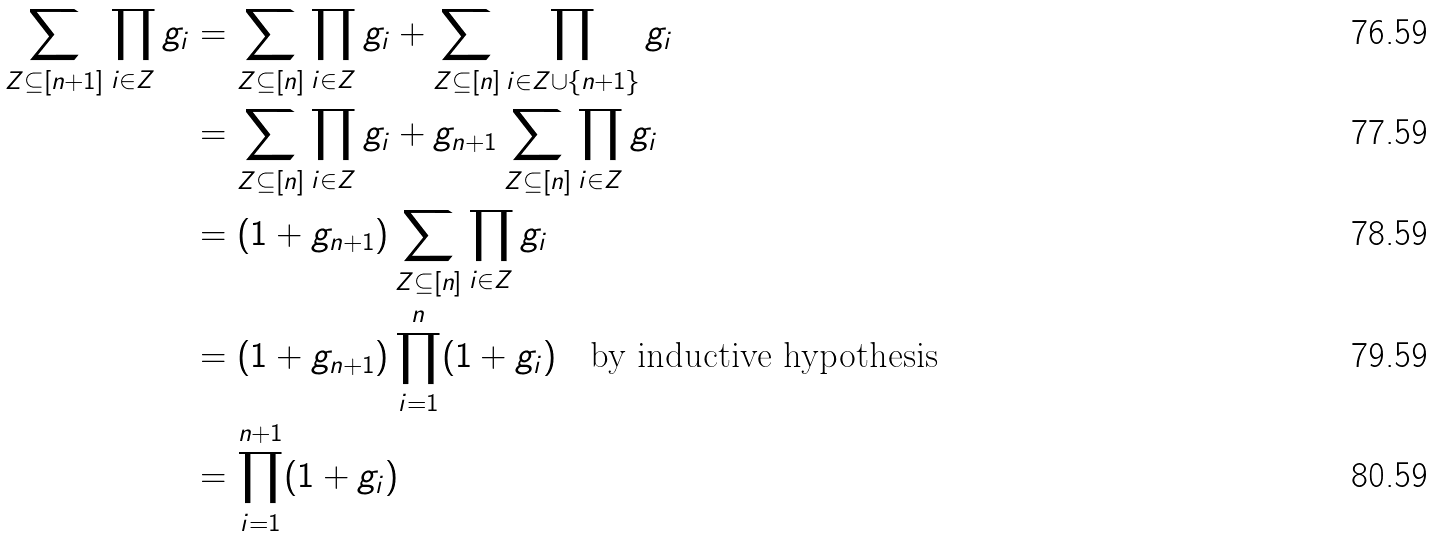<formula> <loc_0><loc_0><loc_500><loc_500>\sum _ { Z \subseteq [ n + 1 ] } \prod _ { i \in Z } g _ { i } & = \sum _ { Z \subseteq [ n ] } \prod _ { i \in Z } g _ { i } + \sum _ { Z \subseteq [ n ] } \prod _ { i \in Z \cup \{ n + 1 \} } g _ { i } \\ & = \sum _ { Z \subseteq [ n ] } \prod _ { i \in Z } g _ { i } + g _ { n + 1 } \sum _ { Z \subseteq [ n ] } \prod _ { i \in Z } g _ { i } \\ & = ( 1 + g _ { n + 1 } ) \sum _ { Z \subseteq [ n ] } \prod _ { i \in Z } g _ { i } \\ & = ( 1 + g _ { n + 1 } ) \prod _ { i = 1 } ^ { n } ( 1 + g _ { i } ) \quad \text {by inductive hypothesis} \\ & = \prod _ { i = 1 } ^ { n + 1 } ( 1 + g _ { i } )</formula> 